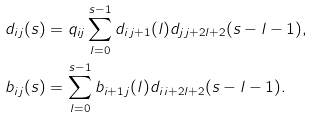Convert formula to latex. <formula><loc_0><loc_0><loc_500><loc_500>d _ { i \, j } ( s ) & = q _ { i j } \sum _ { l = 0 } ^ { s - 1 } d _ { i \, j + 1 } ( l ) d _ { j \, j + 2 l + 2 } ( s - l - 1 ) , \\ b _ { i \, j } ( s ) & = \sum _ { l = 0 } ^ { s - 1 } b _ { i + 1 \, j } ( l ) d _ { i \, i + 2 l + 2 } ( s - l - 1 ) .</formula> 